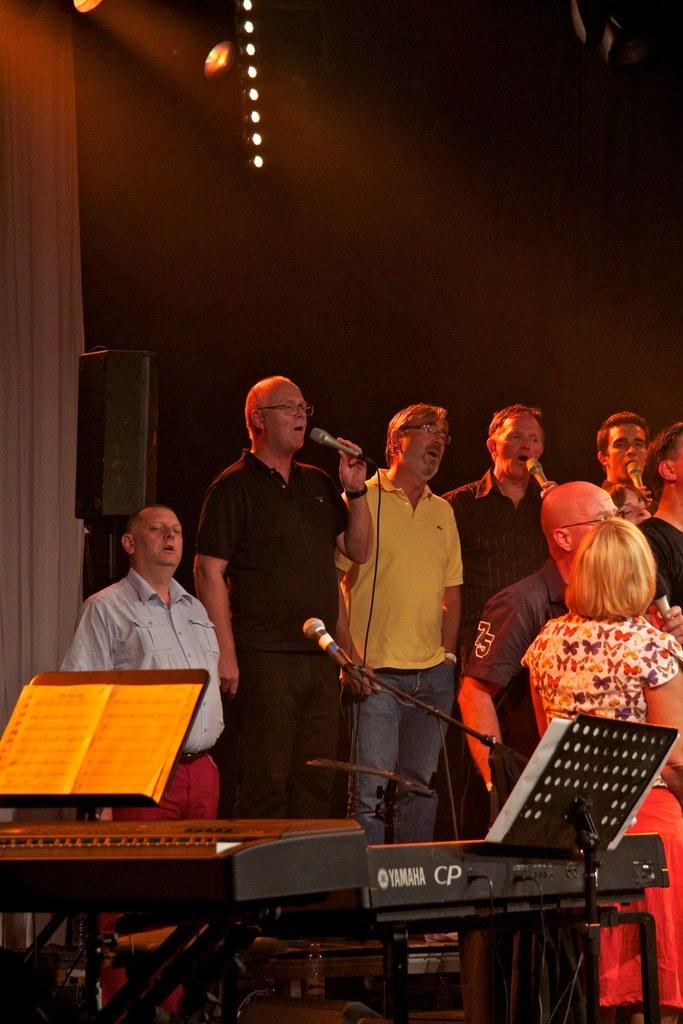<image>
Provide a brief description of the given image. A group of people singing behind a Yamaha piano 